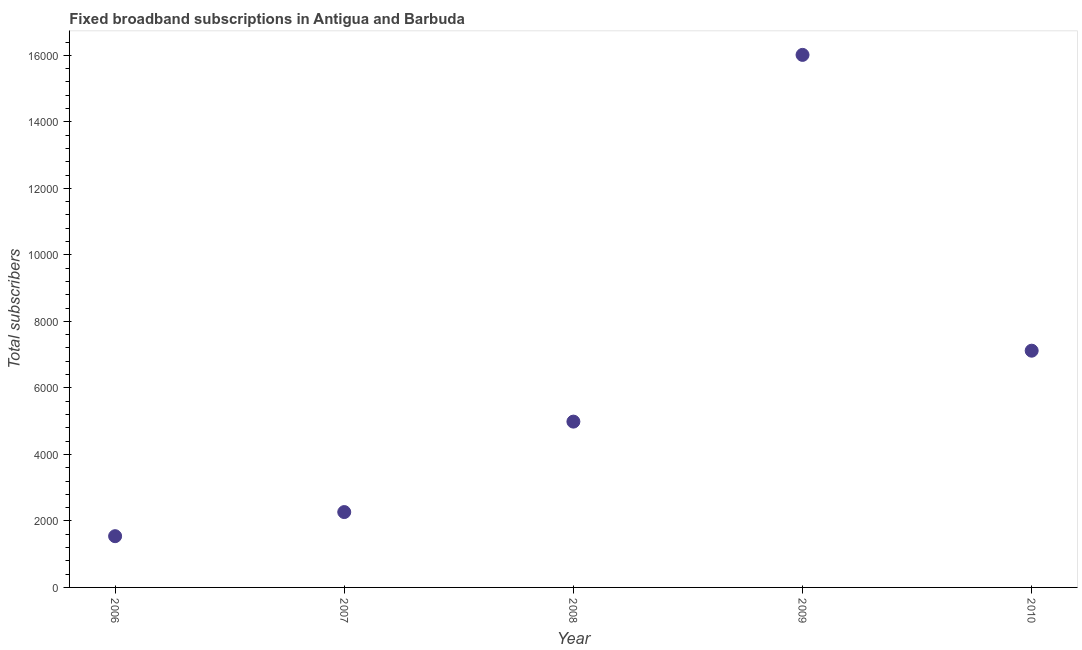What is the total number of fixed broadband subscriptions in 2010?
Provide a short and direct response. 7119. Across all years, what is the maximum total number of fixed broadband subscriptions?
Offer a very short reply. 1.60e+04. Across all years, what is the minimum total number of fixed broadband subscriptions?
Keep it short and to the point. 1541. In which year was the total number of fixed broadband subscriptions maximum?
Make the answer very short. 2009. What is the sum of the total number of fixed broadband subscriptions?
Offer a very short reply. 3.19e+04. What is the difference between the total number of fixed broadband subscriptions in 2008 and 2010?
Your response must be concise. -2133. What is the average total number of fixed broadband subscriptions per year?
Keep it short and to the point. 6385.2. What is the median total number of fixed broadband subscriptions?
Offer a terse response. 4986. In how many years, is the total number of fixed broadband subscriptions greater than 15600 ?
Your response must be concise. 1. Do a majority of the years between 2006 and 2007 (inclusive) have total number of fixed broadband subscriptions greater than 9600 ?
Your answer should be very brief. No. What is the ratio of the total number of fixed broadband subscriptions in 2007 to that in 2008?
Keep it short and to the point. 0.45. Is the total number of fixed broadband subscriptions in 2009 less than that in 2010?
Your answer should be very brief. No. Is the difference between the total number of fixed broadband subscriptions in 2007 and 2008 greater than the difference between any two years?
Keep it short and to the point. No. What is the difference between the highest and the second highest total number of fixed broadband subscriptions?
Your answer should be compact. 8895. Is the sum of the total number of fixed broadband subscriptions in 2008 and 2009 greater than the maximum total number of fixed broadband subscriptions across all years?
Give a very brief answer. Yes. What is the difference between the highest and the lowest total number of fixed broadband subscriptions?
Keep it short and to the point. 1.45e+04. How many dotlines are there?
Your answer should be compact. 1. What is the difference between two consecutive major ticks on the Y-axis?
Give a very brief answer. 2000. Does the graph contain any zero values?
Make the answer very short. No. Does the graph contain grids?
Keep it short and to the point. No. What is the title of the graph?
Give a very brief answer. Fixed broadband subscriptions in Antigua and Barbuda. What is the label or title of the X-axis?
Ensure brevity in your answer.  Year. What is the label or title of the Y-axis?
Keep it short and to the point. Total subscribers. What is the Total subscribers in 2006?
Your answer should be compact. 1541. What is the Total subscribers in 2007?
Your answer should be very brief. 2266. What is the Total subscribers in 2008?
Provide a succinct answer. 4986. What is the Total subscribers in 2009?
Offer a very short reply. 1.60e+04. What is the Total subscribers in 2010?
Your response must be concise. 7119. What is the difference between the Total subscribers in 2006 and 2007?
Give a very brief answer. -725. What is the difference between the Total subscribers in 2006 and 2008?
Your answer should be very brief. -3445. What is the difference between the Total subscribers in 2006 and 2009?
Provide a short and direct response. -1.45e+04. What is the difference between the Total subscribers in 2006 and 2010?
Provide a short and direct response. -5578. What is the difference between the Total subscribers in 2007 and 2008?
Ensure brevity in your answer.  -2720. What is the difference between the Total subscribers in 2007 and 2009?
Keep it short and to the point. -1.37e+04. What is the difference between the Total subscribers in 2007 and 2010?
Keep it short and to the point. -4853. What is the difference between the Total subscribers in 2008 and 2009?
Your answer should be compact. -1.10e+04. What is the difference between the Total subscribers in 2008 and 2010?
Provide a succinct answer. -2133. What is the difference between the Total subscribers in 2009 and 2010?
Give a very brief answer. 8895. What is the ratio of the Total subscribers in 2006 to that in 2007?
Ensure brevity in your answer.  0.68. What is the ratio of the Total subscribers in 2006 to that in 2008?
Offer a very short reply. 0.31. What is the ratio of the Total subscribers in 2006 to that in 2009?
Offer a very short reply. 0.1. What is the ratio of the Total subscribers in 2006 to that in 2010?
Give a very brief answer. 0.22. What is the ratio of the Total subscribers in 2007 to that in 2008?
Provide a succinct answer. 0.45. What is the ratio of the Total subscribers in 2007 to that in 2009?
Provide a succinct answer. 0.14. What is the ratio of the Total subscribers in 2007 to that in 2010?
Give a very brief answer. 0.32. What is the ratio of the Total subscribers in 2008 to that in 2009?
Give a very brief answer. 0.31. What is the ratio of the Total subscribers in 2009 to that in 2010?
Provide a succinct answer. 2.25. 